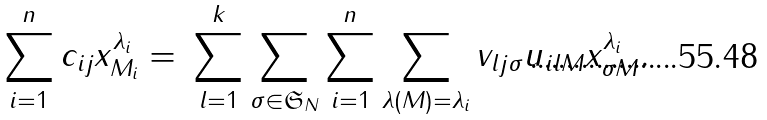Convert formula to latex. <formula><loc_0><loc_0><loc_500><loc_500>\sum _ { i = 1 } ^ { n } { c _ { i j } x _ { M _ { i } } ^ { \lambda _ { i } } } = \ & \sum _ { l = 1 } ^ { k } \sum _ { \sigma \in { \mathfrak S } _ { N } } \sum _ { i = 1 } ^ { n } \sum _ { \lambda ( M ) = \lambda _ { i } } v _ { l j \sigma } u _ { i l M } x _ { \sigma M } ^ { \lambda _ { i } } . \\</formula> 